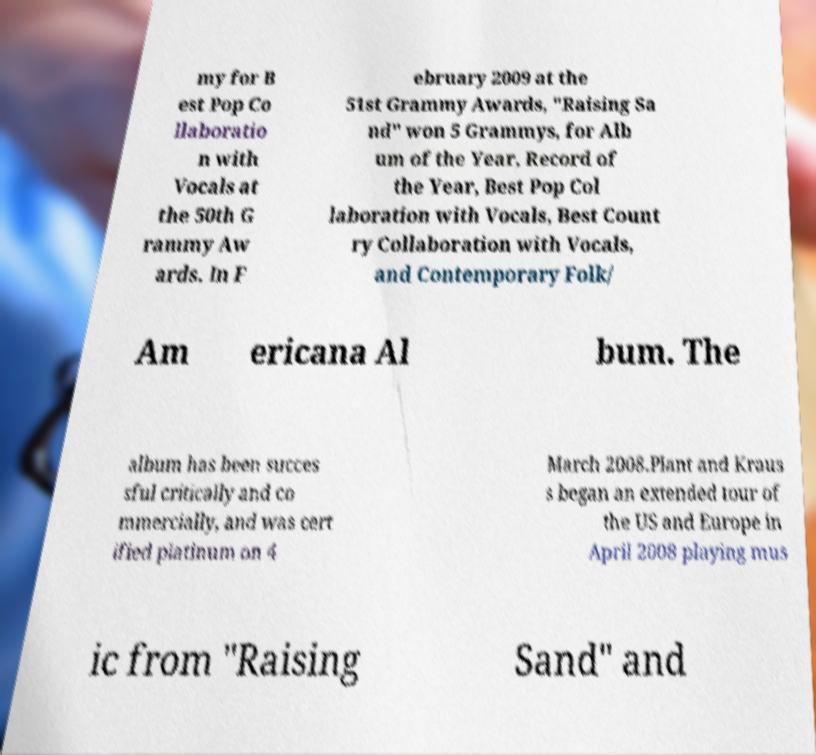Can you read and provide the text displayed in the image?This photo seems to have some interesting text. Can you extract and type it out for me? my for B est Pop Co llaboratio n with Vocals at the 50th G rammy Aw ards. In F ebruary 2009 at the 51st Grammy Awards, "Raising Sa nd" won 5 Grammys, for Alb um of the Year, Record of the Year, Best Pop Col laboration with Vocals, Best Count ry Collaboration with Vocals, and Contemporary Folk/ Am ericana Al bum. The album has been succes sful critically and co mmercially, and was cert ified platinum on 4 March 2008.Plant and Kraus s began an extended tour of the US and Europe in April 2008 playing mus ic from "Raising Sand" and 